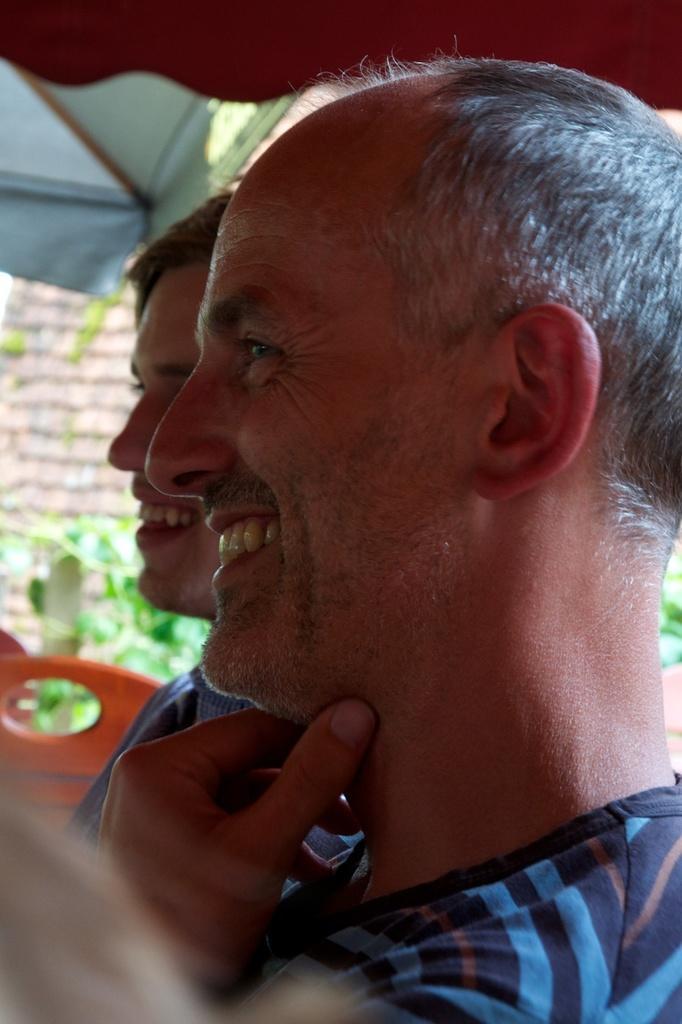Describe this image in one or two sentences. In this image I can see two persons. They are wearing blue color dress. Back I can see small plant and tents. 